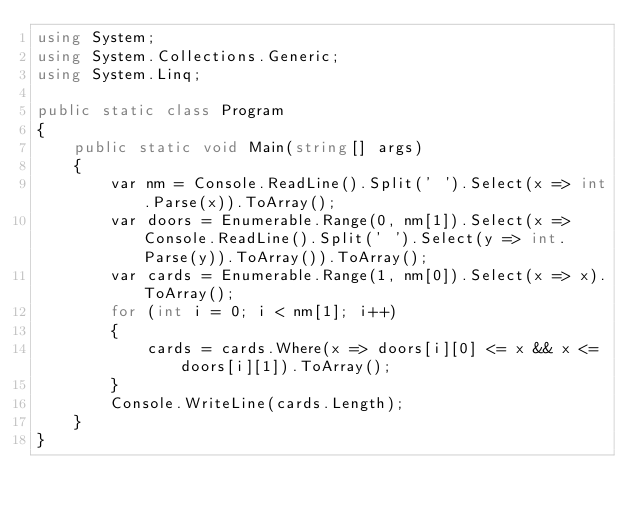<code> <loc_0><loc_0><loc_500><loc_500><_C#_>using System;
using System.Collections.Generic;
using System.Linq;

public static class Program
{
    public static void Main(string[] args)
    {
        var nm = Console.ReadLine().Split(' ').Select(x => int.Parse(x)).ToArray();
        var doors = Enumerable.Range(0, nm[1]).Select(x => Console.ReadLine().Split(' ').Select(y => int.Parse(y)).ToArray()).ToArray();
        var cards = Enumerable.Range(1, nm[0]).Select(x => x).ToArray();
        for (int i = 0; i < nm[1]; i++)
        {
            cards = cards.Where(x => doors[i][0] <= x && x <= doors[i][1]).ToArray();
        }
        Console.WriteLine(cards.Length);
    }
}</code> 